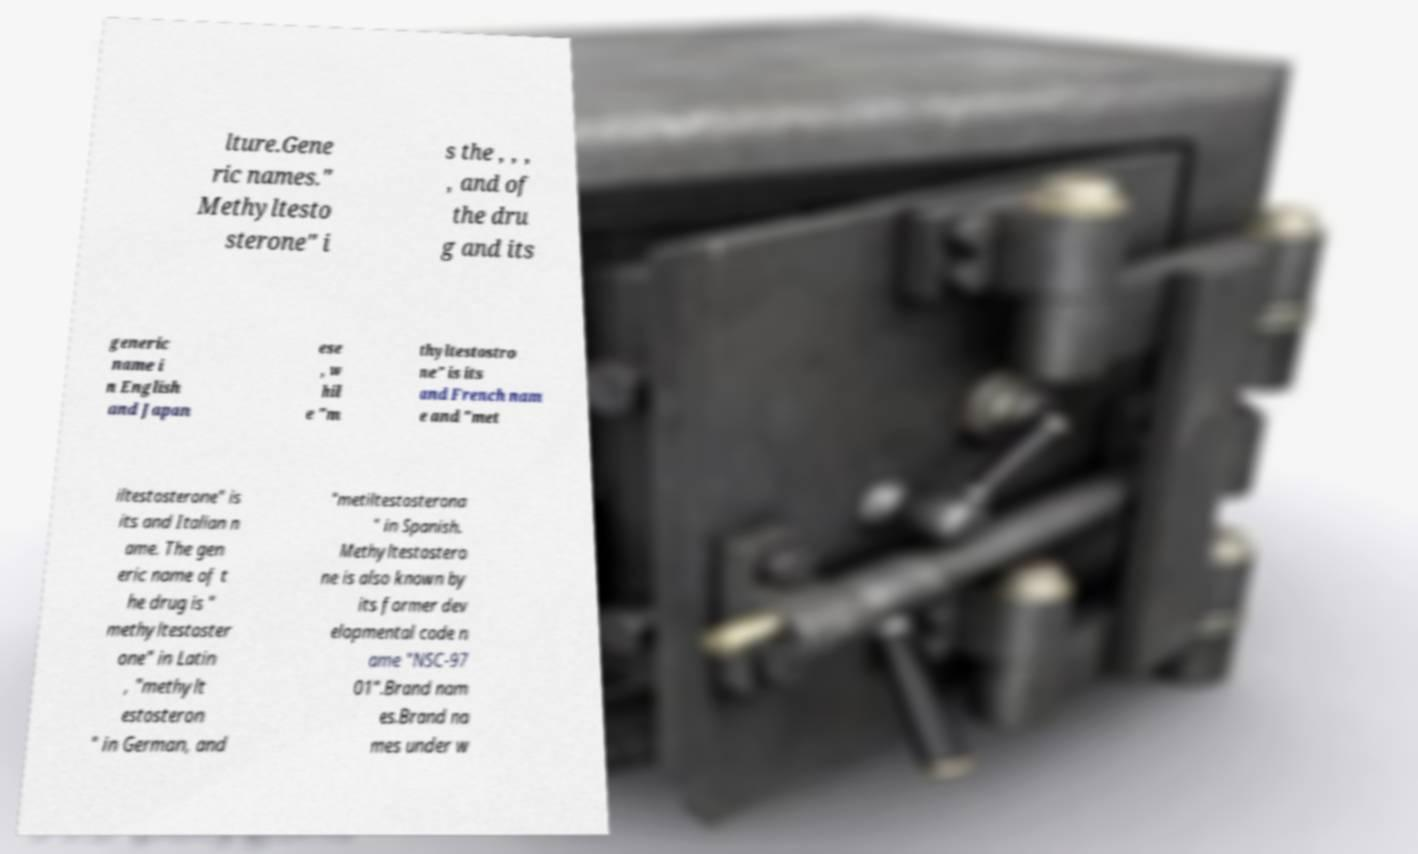There's text embedded in this image that I need extracted. Can you transcribe it verbatim? lture.Gene ric names." Methyltesto sterone" i s the , , , , and of the dru g and its generic name i n English and Japan ese , w hil e "m thyltestostro ne" is its and French nam e and "met iltestosterone" is its and Italian n ame. The gen eric name of t he drug is " methyltestoster one" in Latin , "methylt estosteron " in German, and "metiltestosterona " in Spanish. Methyltestostero ne is also known by its former dev elopmental code n ame "NSC-97 01".Brand nam es.Brand na mes under w 